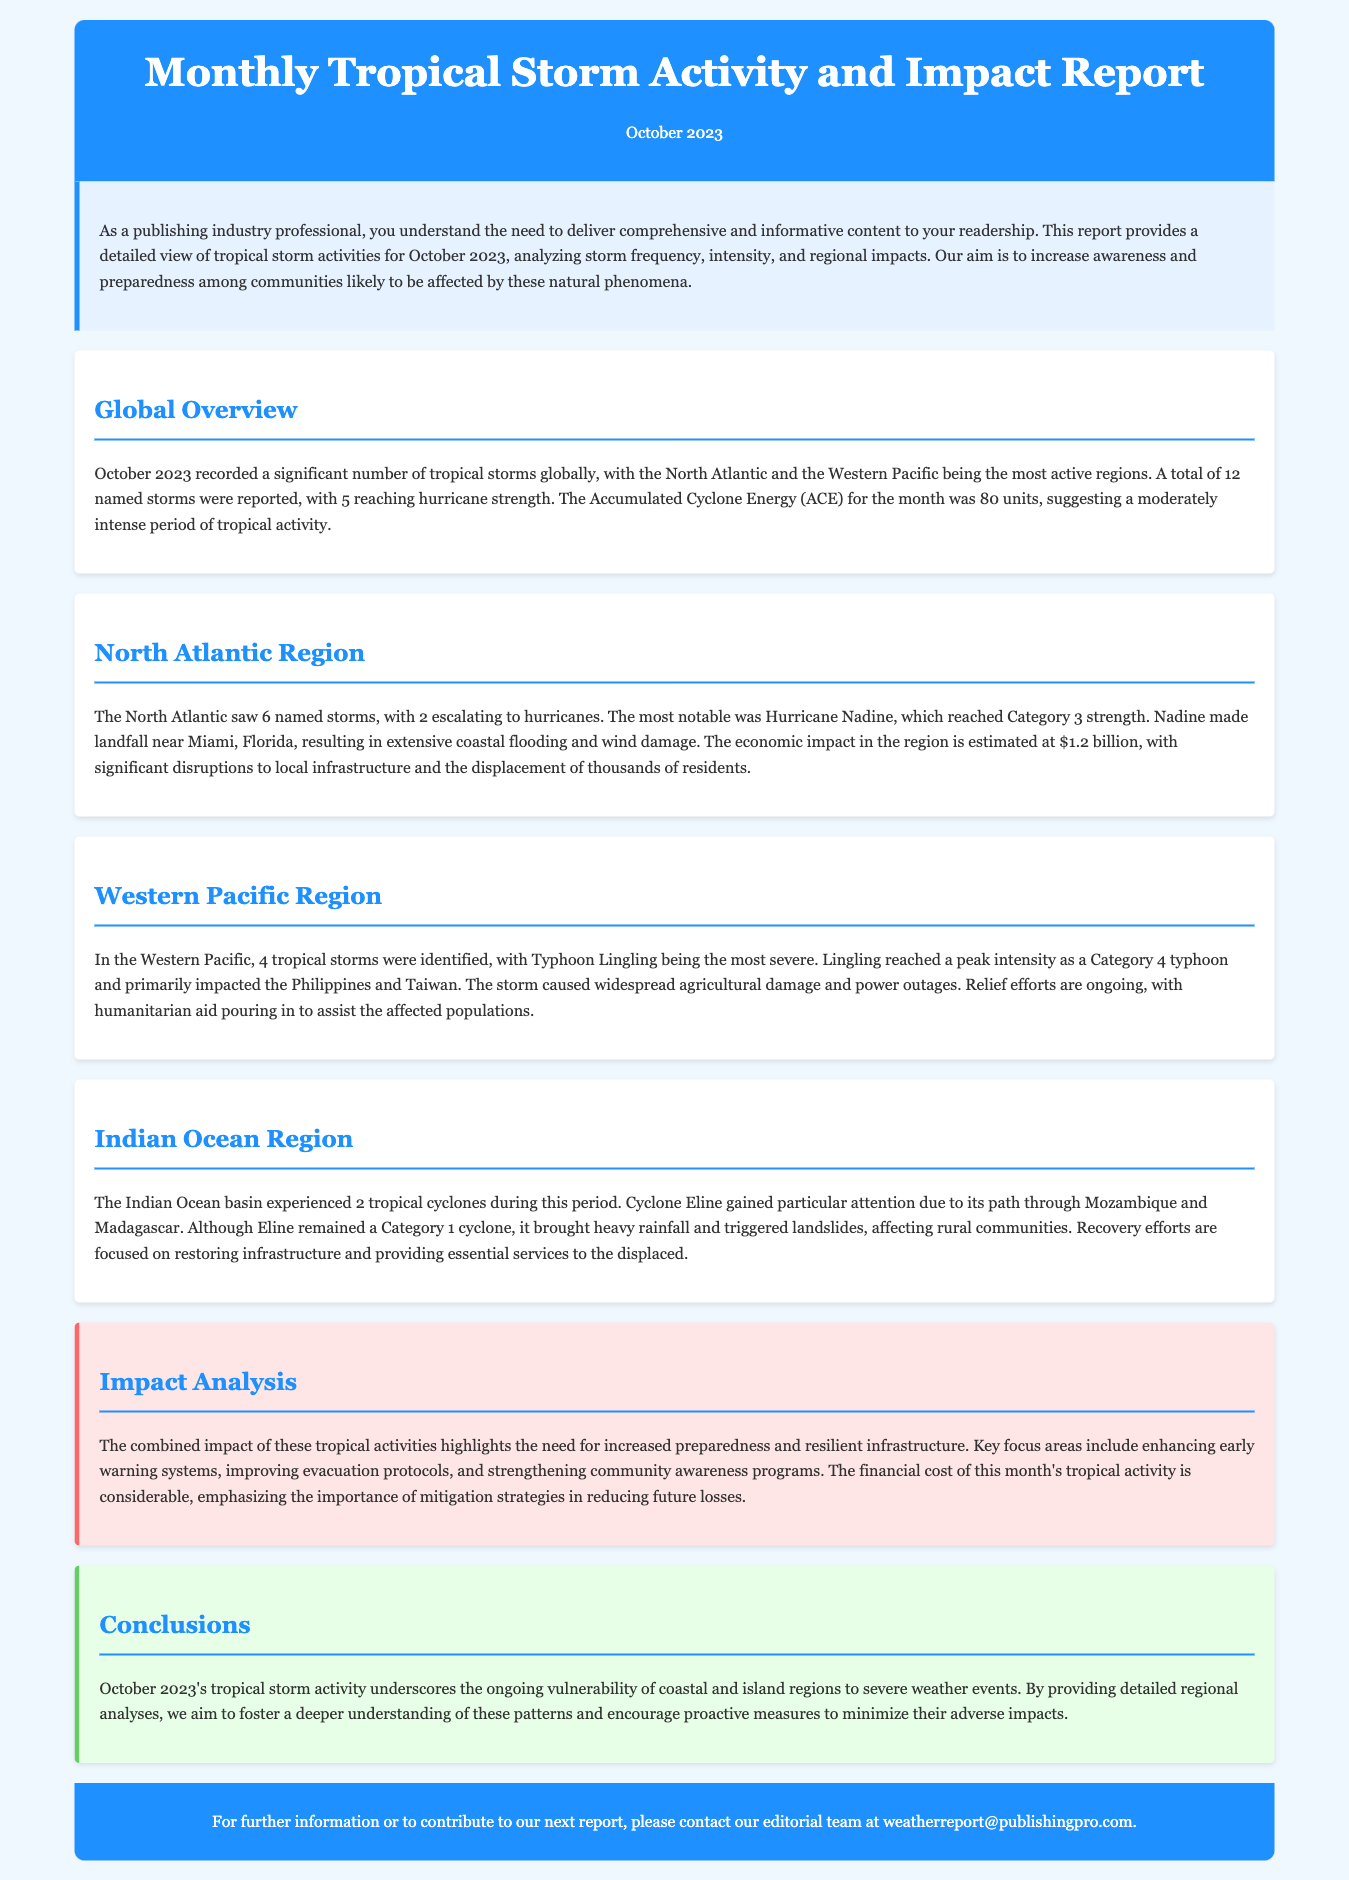What was the total number of named storms reported in October 2023? The document states that a total of 12 named storms were reported in October 2023.
Answer: 12 Which hurricane reached Category 3 strength in the North Atlantic? The report mentions Hurricane Nadine as the hurricane that reached Category 3 strength.
Answer: Hurricane Nadine What was the estimated economic impact of Hurricane Nadine? The document indicates that the economic impact in the region is estimated at $1.2 billion due to Hurricane Nadine.
Answer: $1.2 billion How many tropical storms were identified in the Western Pacific region? According to the report, 4 tropical storms were identified in the Western Pacific region.
Answer: 4 What primary area did Typhoon Lingling impact? The document states that Typhoon Lingling primarily impacted the Philippines and Taiwan.
Answer: Philippines and Taiwan How many tropical cyclones occurred in the Indian Ocean basin? The report mentions that 2 tropical cyclones were experienced in the Indian Ocean basin.
Answer: 2 What major issue is emphasized in the impact analysis section? The document highlights the need for increased preparedness and resilient infrastructure as a major issue.
Answer: Increased preparedness What was the primary focus of recovery efforts following Cyclone Eline? The report notes that recovery efforts are focused on restoring infrastructure and providing essential services to the displaced.
Answer: Restoring infrastructure What type of report is this document classified as? The document is classified as a Monthly Tropical Storm Activity and Impact Report.
Answer: Monthly Tropical Storm Activity and Impact Report 